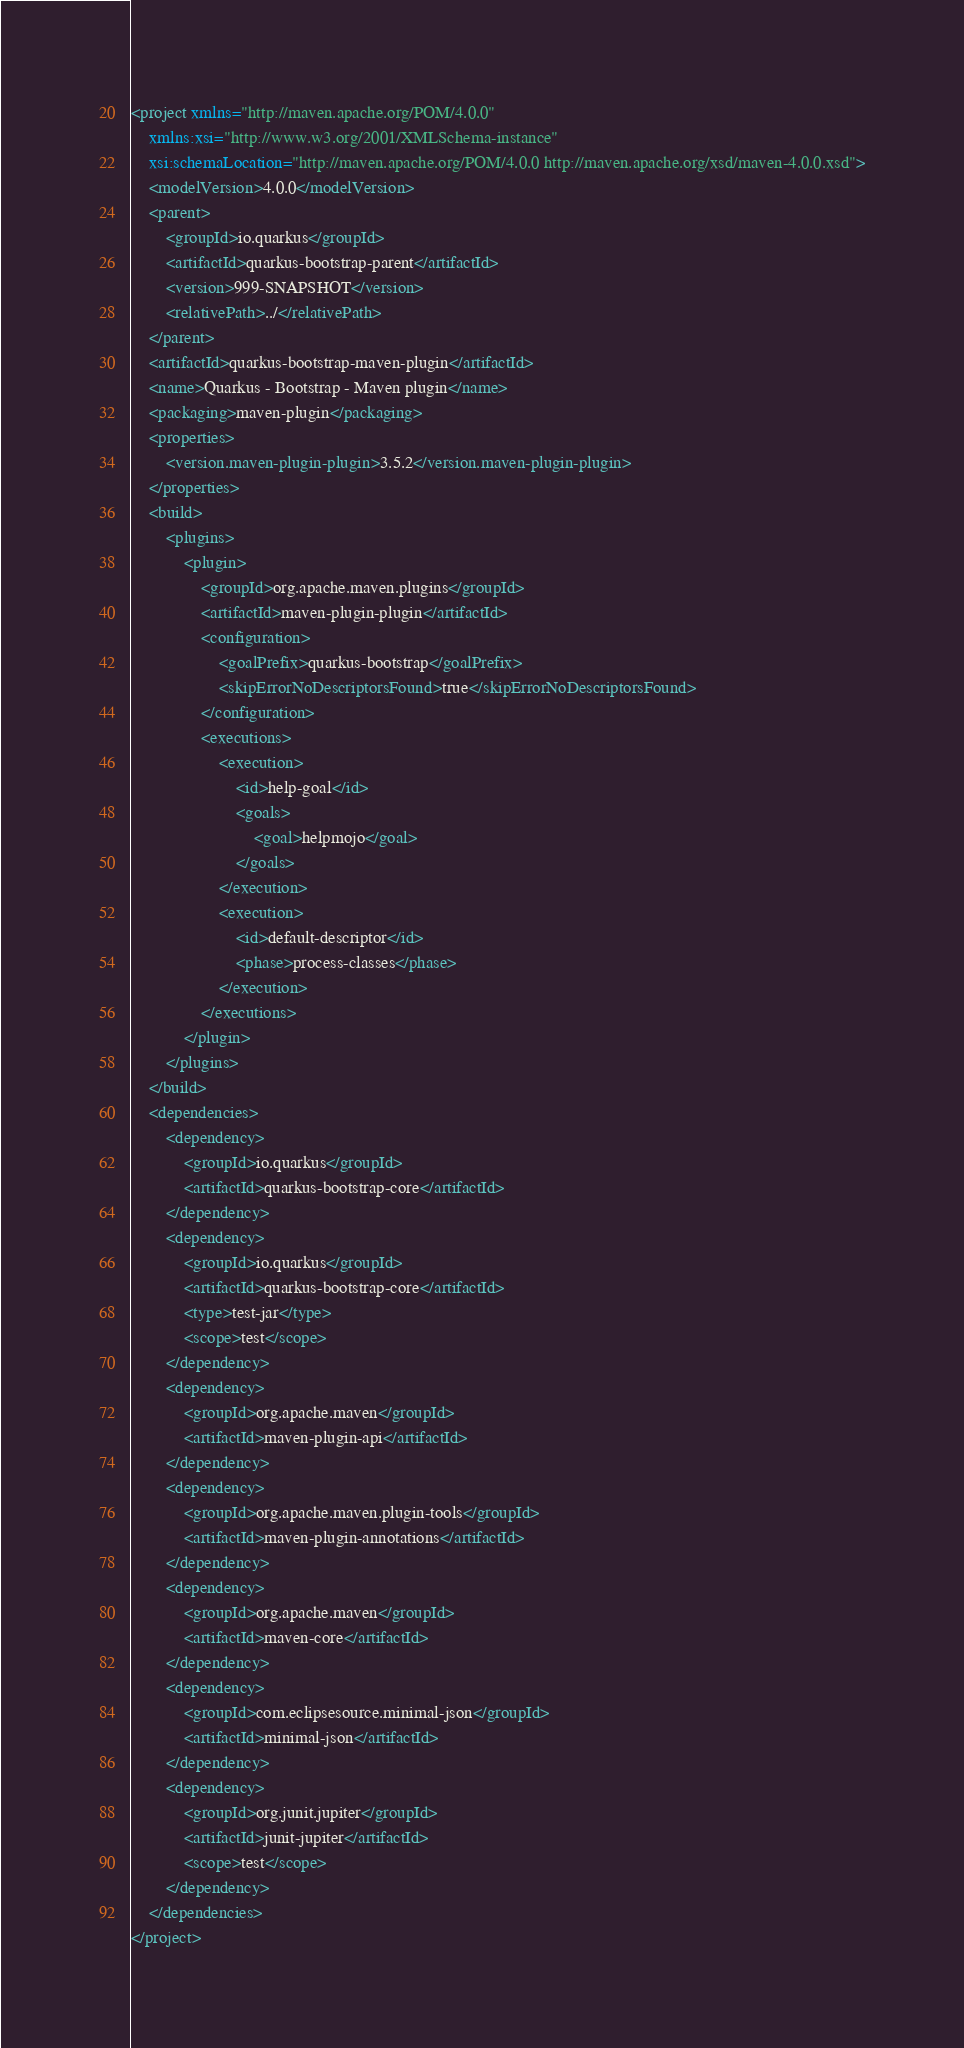<code> <loc_0><loc_0><loc_500><loc_500><_XML_><project xmlns="http://maven.apache.org/POM/4.0.0"
    xmlns:xsi="http://www.w3.org/2001/XMLSchema-instance"
    xsi:schemaLocation="http://maven.apache.org/POM/4.0.0 http://maven.apache.org/xsd/maven-4.0.0.xsd">
    <modelVersion>4.0.0</modelVersion>
    <parent>
        <groupId>io.quarkus</groupId>
        <artifactId>quarkus-bootstrap-parent</artifactId>
        <version>999-SNAPSHOT</version>
        <relativePath>../</relativePath>
    </parent>
    <artifactId>quarkus-bootstrap-maven-plugin</artifactId>
    <name>Quarkus - Bootstrap - Maven plugin</name>
    <packaging>maven-plugin</packaging>
    <properties>
        <version.maven-plugin-plugin>3.5.2</version.maven-plugin-plugin>
    </properties>
    <build>
        <plugins>
            <plugin>
                <groupId>org.apache.maven.plugins</groupId>
                <artifactId>maven-plugin-plugin</artifactId>
                <configuration>
                    <goalPrefix>quarkus-bootstrap</goalPrefix>
                    <skipErrorNoDescriptorsFound>true</skipErrorNoDescriptorsFound>
                </configuration>
                <executions>
                    <execution>
                        <id>help-goal</id>
                        <goals>
                            <goal>helpmojo</goal>
                        </goals>
                    </execution>
                    <execution>
                        <id>default-descriptor</id>
                        <phase>process-classes</phase>
                    </execution>
                </executions>
            </plugin>
        </plugins>
    </build>
    <dependencies>
        <dependency>
            <groupId>io.quarkus</groupId>
            <artifactId>quarkus-bootstrap-core</artifactId>
        </dependency>
        <dependency>
            <groupId>io.quarkus</groupId>
            <artifactId>quarkus-bootstrap-core</artifactId>
            <type>test-jar</type>
            <scope>test</scope>
        </dependency>
        <dependency>
            <groupId>org.apache.maven</groupId>
            <artifactId>maven-plugin-api</artifactId>
        </dependency>
        <dependency>
            <groupId>org.apache.maven.plugin-tools</groupId>
            <artifactId>maven-plugin-annotations</artifactId>
        </dependency>
        <dependency>
            <groupId>org.apache.maven</groupId>
            <artifactId>maven-core</artifactId>
        </dependency>
        <dependency>
            <groupId>com.eclipsesource.minimal-json</groupId>
            <artifactId>minimal-json</artifactId>
        </dependency>
        <dependency>
            <groupId>org.junit.jupiter</groupId>
            <artifactId>junit-jupiter</artifactId>
            <scope>test</scope>
        </dependency>
    </dependencies>
</project>
</code> 